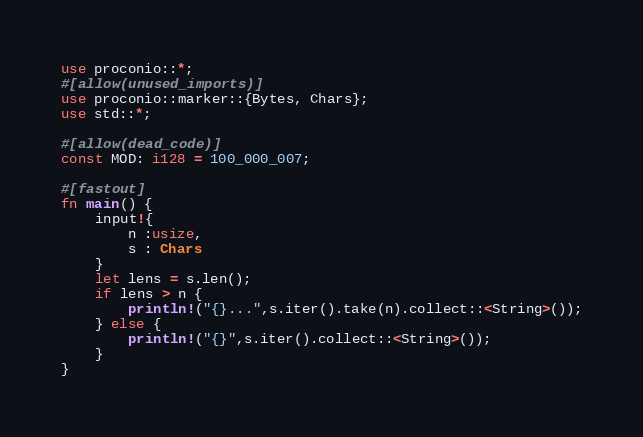Convert code to text. <code><loc_0><loc_0><loc_500><loc_500><_Rust_>use proconio::*;
#[allow(unused_imports)]
use proconio::marker::{Bytes, Chars};
use std::*;

#[allow(dead_code)]
const MOD: i128 = 100_000_007;

#[fastout]
fn main() {
    input!{
        n :usize,
        s : Chars
    }
    let lens = s.len();
    if lens > n {
        println!("{}...",s.iter().take(n).collect::<String>());
    } else {
        println!("{}",s.iter().collect::<String>());
    }
}
</code> 